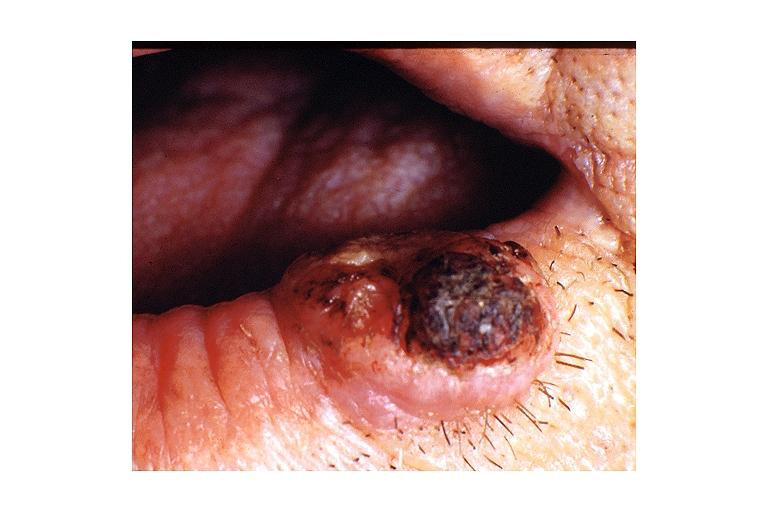where is this?
Answer the question using a single word or phrase. Oral 